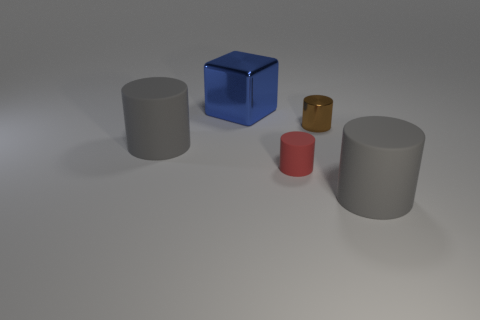Add 3 tiny rubber cylinders. How many objects exist? 8 Subtract all cubes. How many objects are left? 4 Subtract all small metallic cylinders. Subtract all big blue shiny blocks. How many objects are left? 3 Add 3 tiny brown metal things. How many tiny brown metal things are left? 4 Add 3 big gray rubber objects. How many big gray rubber objects exist? 5 Subtract 1 brown cylinders. How many objects are left? 4 